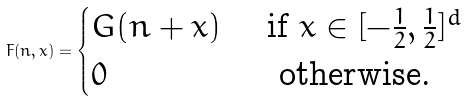<formula> <loc_0><loc_0><loc_500><loc_500>F ( n , x ) = \begin{cases} G ( n + x ) \ & \text {if $x\in[-\frac{1}{2},\frac{1}{2}]^{d}$} \\ 0 & \text { otherwise.} \end{cases}</formula> 